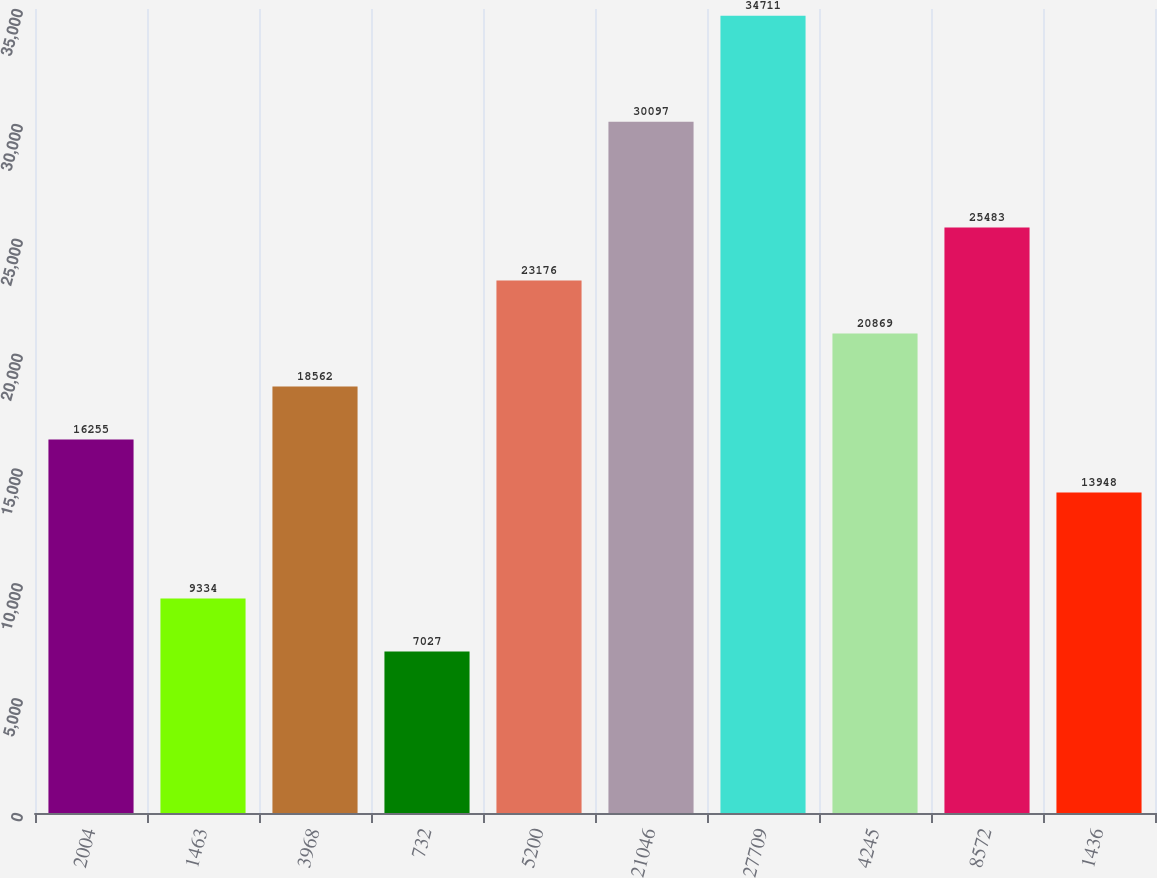<chart> <loc_0><loc_0><loc_500><loc_500><bar_chart><fcel>2004<fcel>1463<fcel>3968<fcel>732<fcel>5200<fcel>21046<fcel>27709<fcel>4245<fcel>8572<fcel>1436<nl><fcel>16255<fcel>9334<fcel>18562<fcel>7027<fcel>23176<fcel>30097<fcel>34711<fcel>20869<fcel>25483<fcel>13948<nl></chart> 